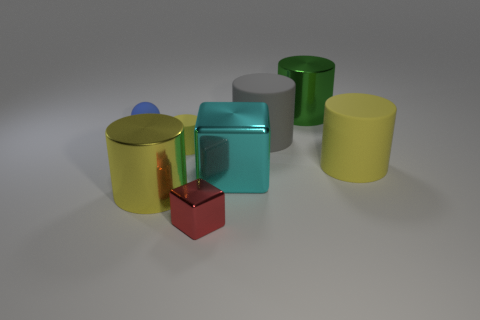Subtract all green blocks. How many yellow cylinders are left? 3 Subtract all green cylinders. How many cylinders are left? 4 Subtract all gray matte cylinders. How many cylinders are left? 4 Subtract all cyan cylinders. Subtract all red cubes. How many cylinders are left? 5 Add 2 tiny metallic blocks. How many objects exist? 10 Subtract all cubes. How many objects are left? 6 Subtract all cubes. Subtract all tiny yellow cylinders. How many objects are left? 5 Add 4 balls. How many balls are left? 5 Add 2 gray rubber cylinders. How many gray rubber cylinders exist? 3 Subtract 0 purple cylinders. How many objects are left? 8 